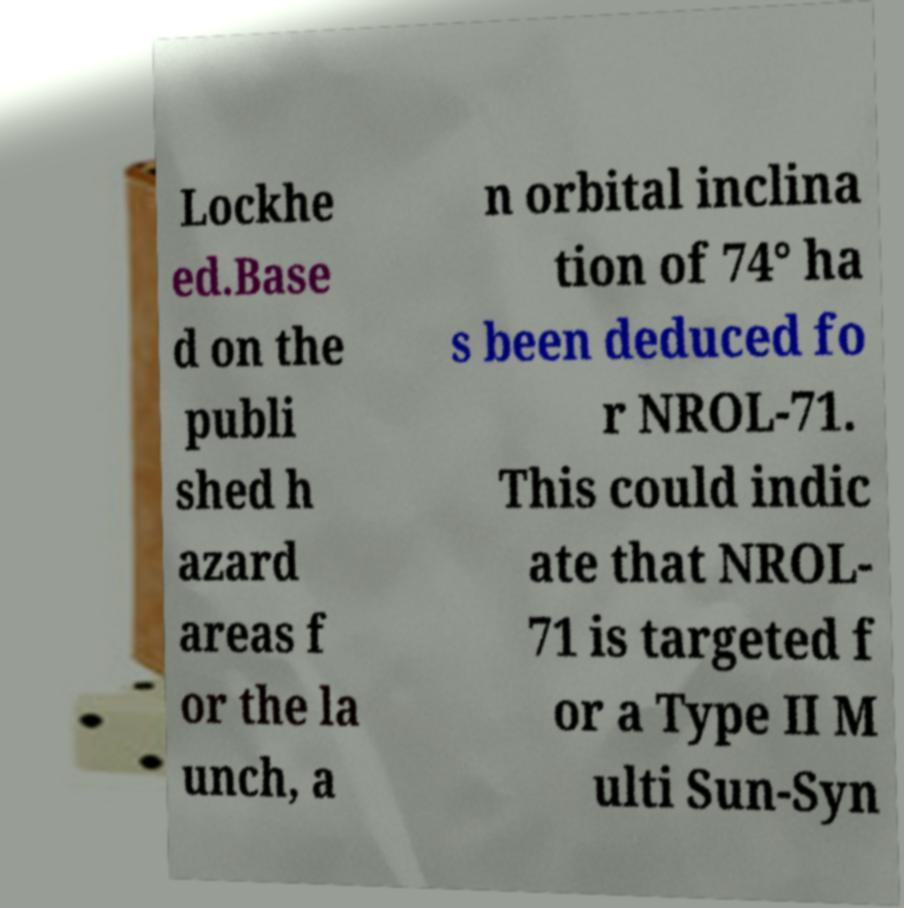What messages or text are displayed in this image? I need them in a readable, typed format. Lockhe ed.Base d on the publi shed h azard areas f or the la unch, a n orbital inclina tion of 74° ha s been deduced fo r NROL-71. This could indic ate that NROL- 71 is targeted f or a Type II M ulti Sun-Syn 